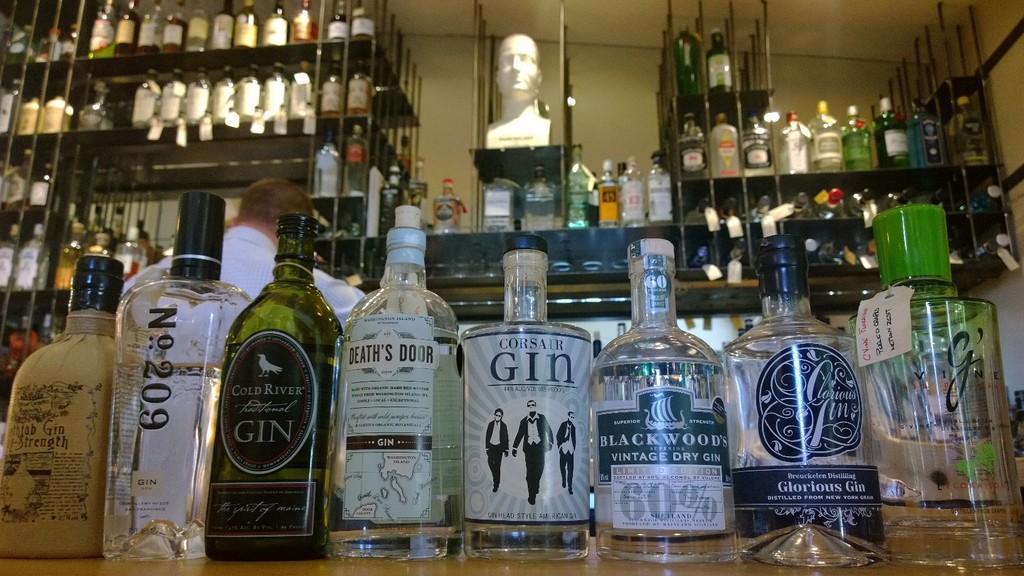Please provide a concise description of this image. In this image there are group of bottles kept on the table and which are kept in the rack. The background wall is white in color. In the middle sculptor is there. This image is taken inside a bar shop. 